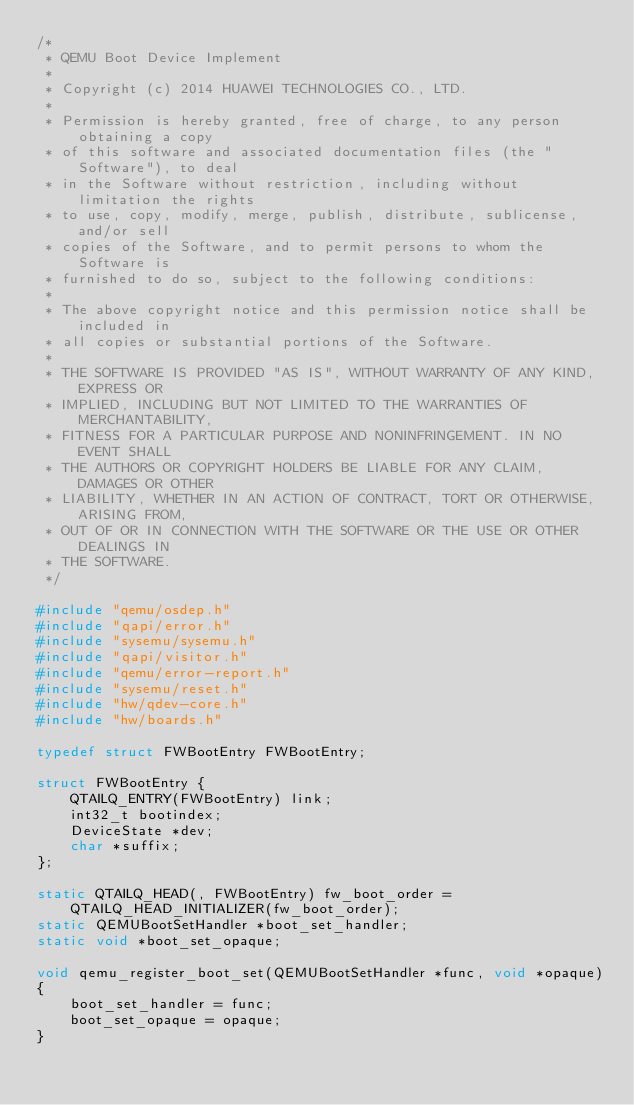<code> <loc_0><loc_0><loc_500><loc_500><_C_>/*
 * QEMU Boot Device Implement
 *
 * Copyright (c) 2014 HUAWEI TECHNOLOGIES CO., LTD.
 *
 * Permission is hereby granted, free of charge, to any person obtaining a copy
 * of this software and associated documentation files (the "Software"), to deal
 * in the Software without restriction, including without limitation the rights
 * to use, copy, modify, merge, publish, distribute, sublicense, and/or sell
 * copies of the Software, and to permit persons to whom the Software is
 * furnished to do so, subject to the following conditions:
 *
 * The above copyright notice and this permission notice shall be included in
 * all copies or substantial portions of the Software.
 *
 * THE SOFTWARE IS PROVIDED "AS IS", WITHOUT WARRANTY OF ANY KIND, EXPRESS OR
 * IMPLIED, INCLUDING BUT NOT LIMITED TO THE WARRANTIES OF MERCHANTABILITY,
 * FITNESS FOR A PARTICULAR PURPOSE AND NONINFRINGEMENT. IN NO EVENT SHALL
 * THE AUTHORS OR COPYRIGHT HOLDERS BE LIABLE FOR ANY CLAIM, DAMAGES OR OTHER
 * LIABILITY, WHETHER IN AN ACTION OF CONTRACT, TORT OR OTHERWISE, ARISING FROM,
 * OUT OF OR IN CONNECTION WITH THE SOFTWARE OR THE USE OR OTHER DEALINGS IN
 * THE SOFTWARE.
 */

#include "qemu/osdep.h"
#include "qapi/error.h"
#include "sysemu/sysemu.h"
#include "qapi/visitor.h"
#include "qemu/error-report.h"
#include "sysemu/reset.h"
#include "hw/qdev-core.h"
#include "hw/boards.h"

typedef struct FWBootEntry FWBootEntry;

struct FWBootEntry {
    QTAILQ_ENTRY(FWBootEntry) link;
    int32_t bootindex;
    DeviceState *dev;
    char *suffix;
};

static QTAILQ_HEAD(, FWBootEntry) fw_boot_order =
    QTAILQ_HEAD_INITIALIZER(fw_boot_order);
static QEMUBootSetHandler *boot_set_handler;
static void *boot_set_opaque;

void qemu_register_boot_set(QEMUBootSetHandler *func, void *opaque)
{
    boot_set_handler = func;
    boot_set_opaque = opaque;
}
</code> 